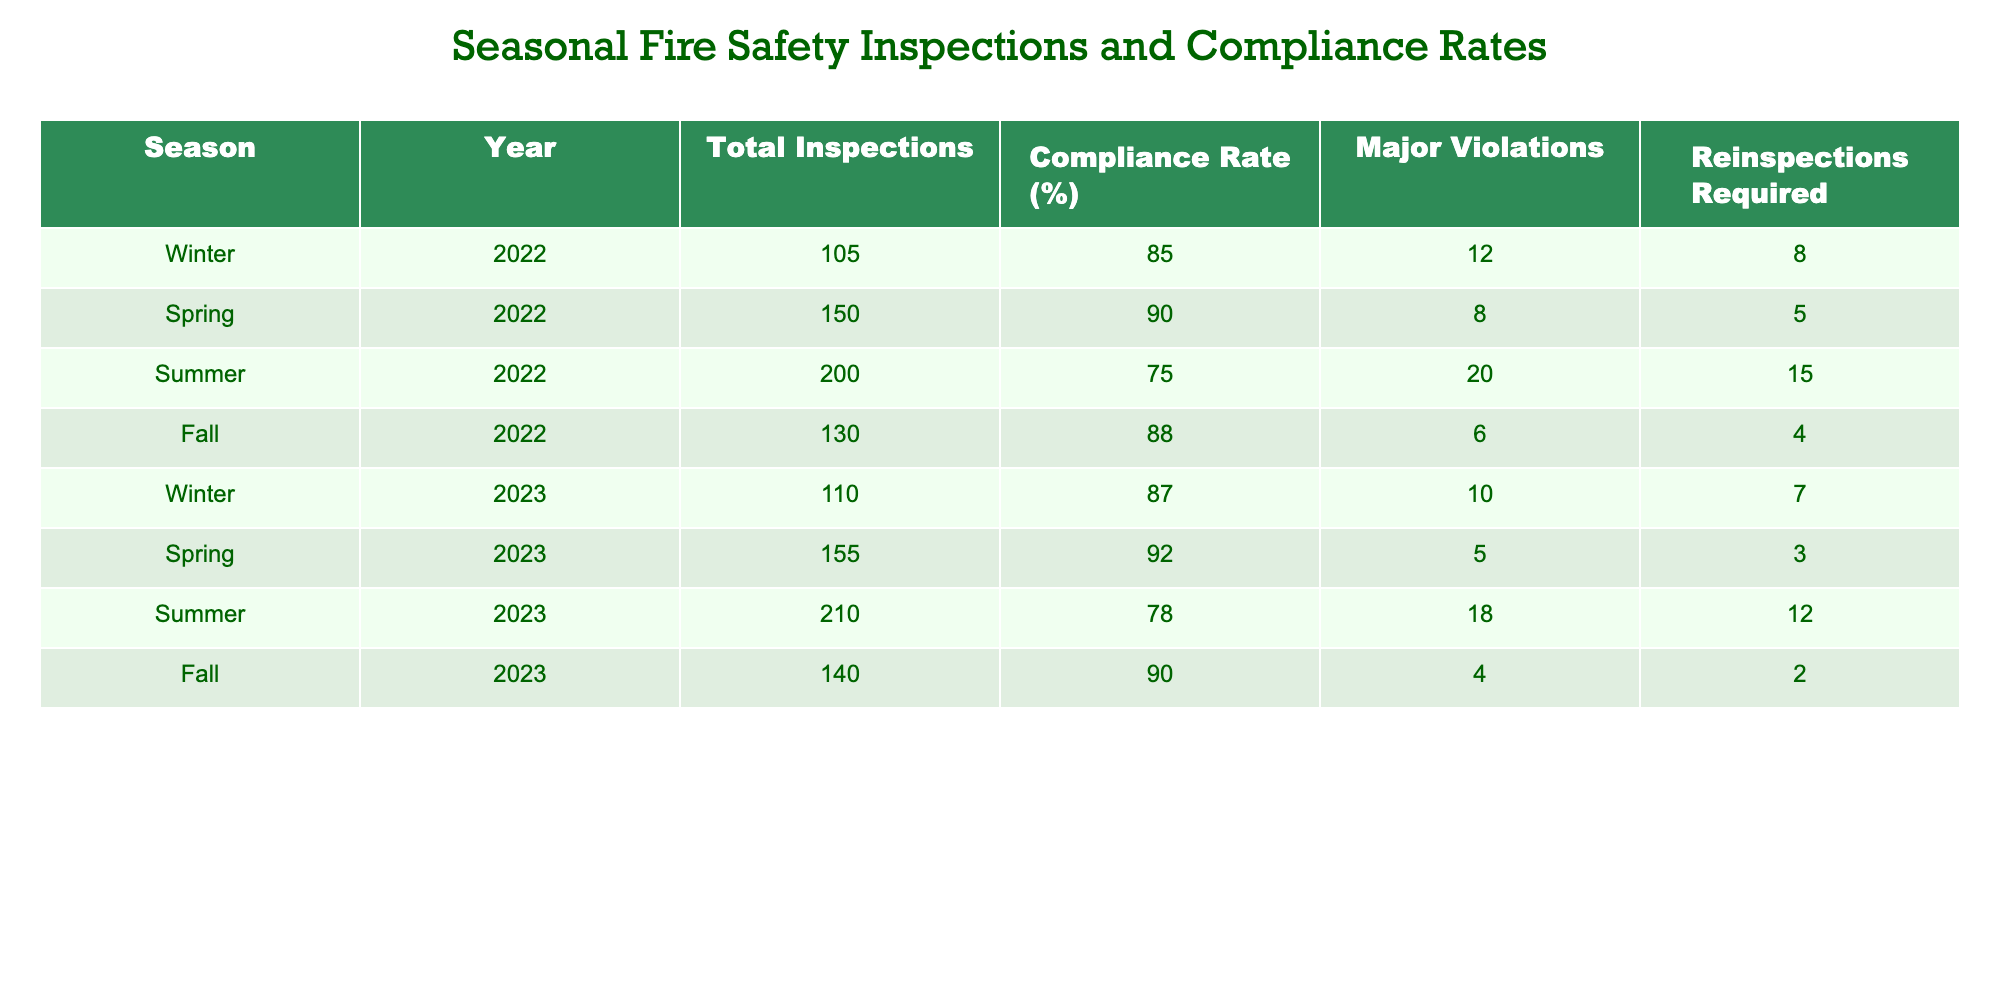What was the total number of fire safety inspections conducted in Summer 2022? In the table, the row corresponding to Summer 2022 shows the total inspections as 200.
Answer: 200 What is the compliance rate for Spring 2023? The compliance rate for Spring 2023 is listed in the table as 92%.
Answer: 92% How many major violations were recorded in Fall 2022? Referring to the table, the major violations for Fall 2022 are recorded as 6.
Answer: 6 What is the average compliance rate across all seasons in 2022? To find the average compliance rate for 2022, we take the compliance rates for each season (85, 90, 75, 88), sum them up (85 + 90 + 75 + 88 = 338), and divide by the number of seasons (4). The average is 338/4 = 84.5.
Answer: 84.5 Was there an increase in total inspections from Winter 2022 to Winter 2023? Comparing the total inspections for Winter 2022 (105) and Winter 2023 (110), there is an increase of 5 inspections. Hence, it is true that there was an increase.
Answer: Yes Which season had the highest number of major violations in 2023? Looking at the data for 2023, Summer had the highest number of major violations with 18, while the other seasons had fewer.
Answer: Summer What is the total number of reinspections required across all seasons in 2022? From the table, we sum the reinspections required for each season in 2022 (8 + 5 + 15 + 4 = 32). Thus, the total is 32.
Answer: 32 Did the compliance rate in Fall 2023 surpass 85%? The compliance rate for Fall 2023 is recorded as 90%, which is indeed greater than 85%.
Answer: Yes Which season showed the lowest compliance rate, and what was that rate? The row for Summer 2022 shows the lowest compliance rate of 75%.
Answer: Summer 2022, 75% 